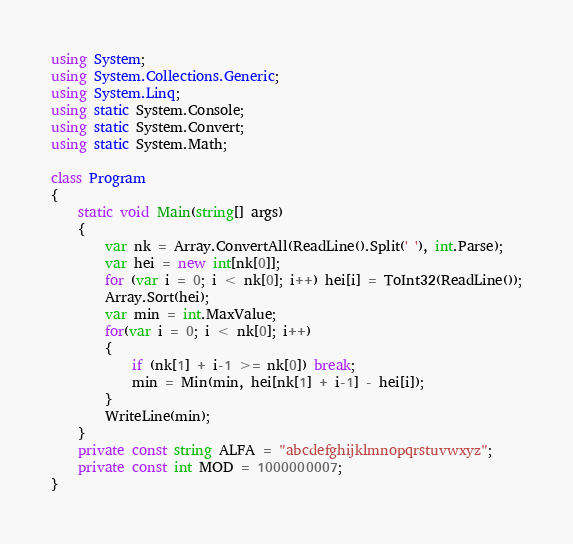<code> <loc_0><loc_0><loc_500><loc_500><_C#_>using System;
using System.Collections.Generic;
using System.Linq;
using static System.Console;
using static System.Convert;
using static System.Math;

class Program
{
    static void Main(string[] args)
    {
        var nk = Array.ConvertAll(ReadLine().Split(' '), int.Parse);
        var hei = new int[nk[0]];
        for (var i = 0; i < nk[0]; i++) hei[i] = ToInt32(ReadLine());
        Array.Sort(hei);
        var min = int.MaxValue;
        for(var i = 0; i < nk[0]; i++)
        {
            if (nk[1] + i-1 >= nk[0]) break;
            min = Min(min, hei[nk[1] + i-1] - hei[i]);
        }
        WriteLine(min);
    }
    private const string ALFA = "abcdefghijklmnopqrstuvwxyz";
    private const int MOD = 1000000007;
}
</code> 